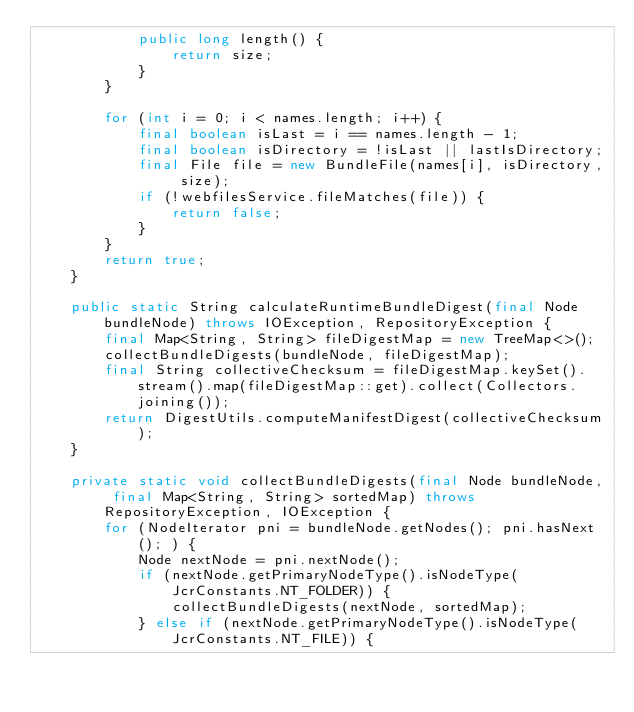<code> <loc_0><loc_0><loc_500><loc_500><_Java_>            public long length() {
                return size;
            }
        }

        for (int i = 0; i < names.length; i++) {
            final boolean isLast = i == names.length - 1;
            final boolean isDirectory = !isLast || lastIsDirectory;
            final File file = new BundleFile(names[i], isDirectory, size);
            if (!webfilesService.fileMatches(file)) {
                return false;
            }
        }
        return true;
    }

    public static String calculateRuntimeBundleDigest(final Node bundleNode) throws IOException, RepositoryException {
        final Map<String, String> fileDigestMap = new TreeMap<>();
        collectBundleDigests(bundleNode, fileDigestMap);
        final String collectiveChecksum = fileDigestMap.keySet().stream().map(fileDigestMap::get).collect(Collectors.joining());
        return DigestUtils.computeManifestDigest(collectiveChecksum);
    }

    private static void collectBundleDigests(final Node bundleNode, final Map<String, String> sortedMap) throws RepositoryException, IOException {
        for (NodeIterator pni = bundleNode.getNodes(); pni.hasNext(); ) {
            Node nextNode = pni.nextNode();
            if (nextNode.getPrimaryNodeType().isNodeType(JcrConstants.NT_FOLDER)) {
                collectBundleDigests(nextNode, sortedMap);
            } else if (nextNode.getPrimaryNodeType().isNodeType(JcrConstants.NT_FILE)) {</code> 